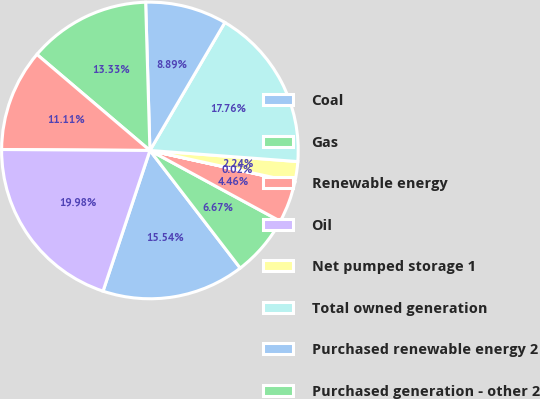<chart> <loc_0><loc_0><loc_500><loc_500><pie_chart><fcel>Coal<fcel>Gas<fcel>Renewable energy<fcel>Oil<fcel>Net pumped storage 1<fcel>Total owned generation<fcel>Purchased renewable energy 2<fcel>Purchased generation - other 2<fcel>Net interchange power 3<fcel>Total purchased and<nl><fcel>15.54%<fcel>6.67%<fcel>4.46%<fcel>0.02%<fcel>2.24%<fcel>17.76%<fcel>8.89%<fcel>13.33%<fcel>11.11%<fcel>19.98%<nl></chart> 